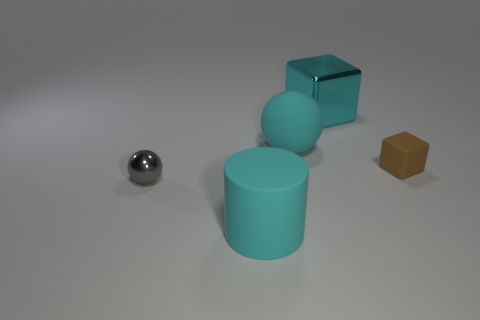What material is the large sphere that is the same color as the metal block? Based on the image, the large sphere shares the same color as the metal block, suggesting they might be composed of similar materials. However, without specific details on the texture or properties of the objects, it's challenging to definitively conclude the material of the sphere. It could be a matte plastic or even a painted surface that mimics the appearance of metal. 